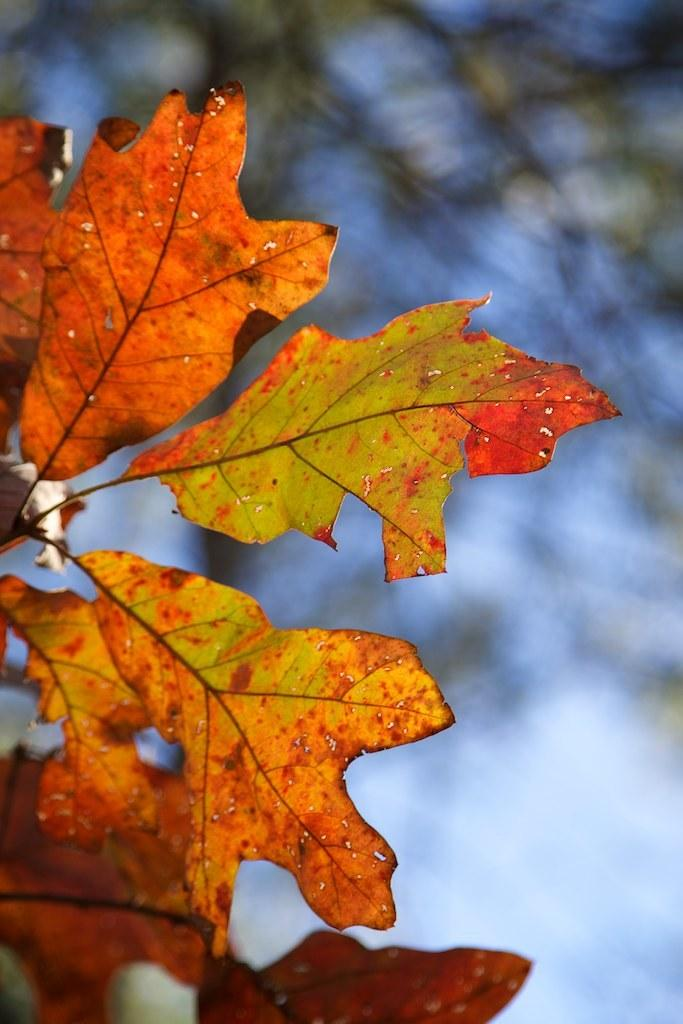What type of natural elements can be seen in the image? There are dried leaves in orange and green colors in the image. What is visible in the background of the image? There are trees in the background of the image. What color are the trees in the image? The trees are green in color. What color is the sky in the image? The sky is blue in color. How does the wealth of the trees in the image contribute to their growth? There is no indication of wealth in the image, as it features dried leaves, trees, and the sky. The growth of the trees is not related to their wealth. 